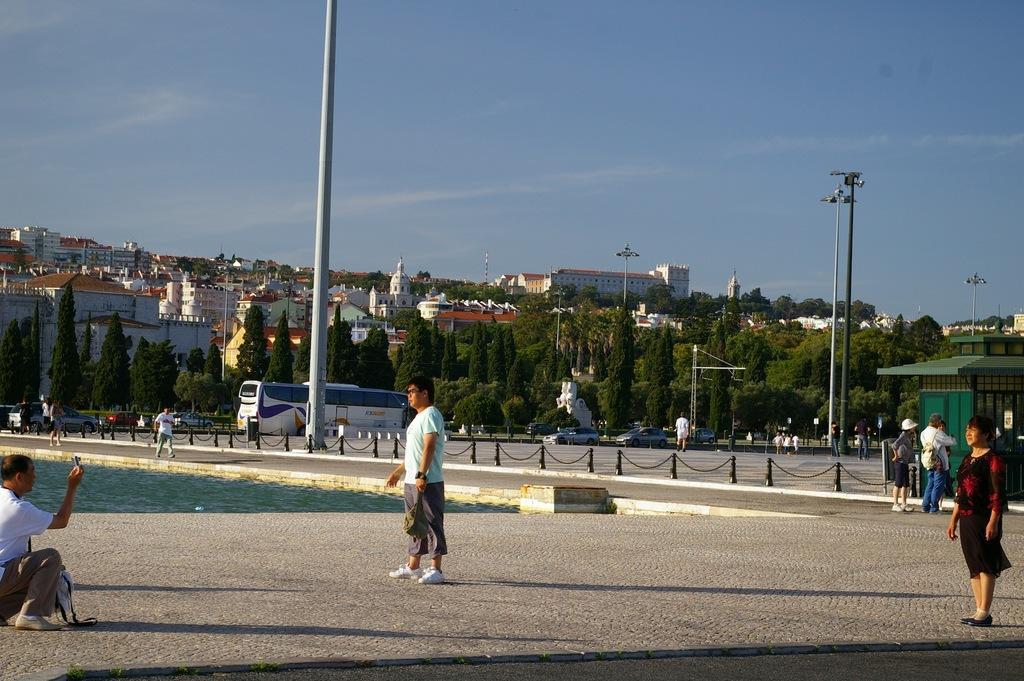Could you give a brief overview of what you see in this image? In this image we can see some people on the ground. One person is holding an object in his hand. On the left side of the image we can see water. In the center of the image we can see a group of trees, poles and some chains. In the background, we can see a group of buildings with windows. At the top of the image we can see the sky. 